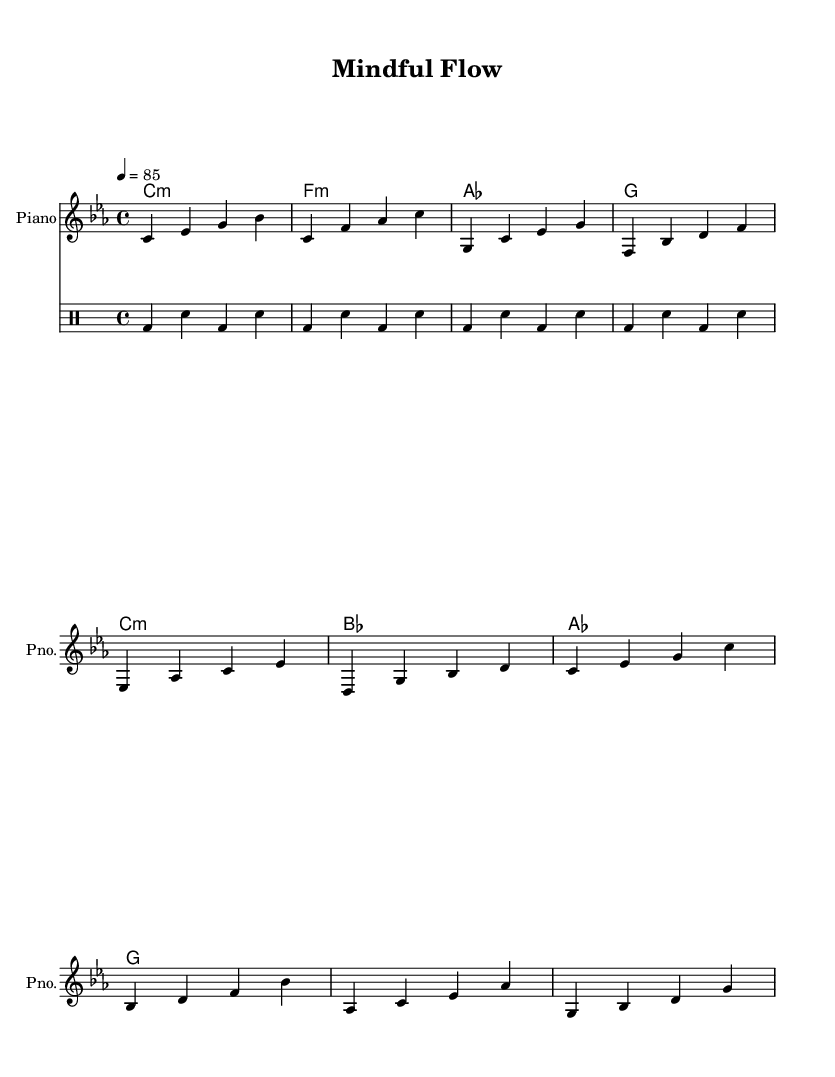What is the key signature of this music? The key signature is found at the beginning of the staff, showing that there are three flats, which indicates it is in C minor.
Answer: C minor What is the time signature of the piece? The time signature can be observed at the start of the score, where it indicates 4/4, meaning there are four beats in each measure and a quarter note receives one beat.
Answer: 4/4 What is the tempo of the piece? The tempo is indicated by a number and a note value at the beginning, which states 4 equals 85, meaning the quarter note is to be played at a speed of 85 beats per minute.
Answer: 85 How many measures are there in the intro section? Counting the measures in the intro part, we see there are 2 measures composed of various notes.
Answer: 2 What is the main chord used in the verse? The verse section shows a pattern of chords with C minor being the primary chord before moving to others like F minor and D minor.
Answer: C minor Which sections feature a repeated drum pattern? The drum staff shows a repeating pattern over four measures, indicating it is meant to loop throughout this part of the music.
Answer: Four measures What reflects the introspective nature of this rap? Through analyzing the lyrics structure and the emotional chords used in combination with the instrumentation, one can identify that the music focuses on deep, personal themes associated with mindfulness and emotional exploration.
Answer: Emotional chords 